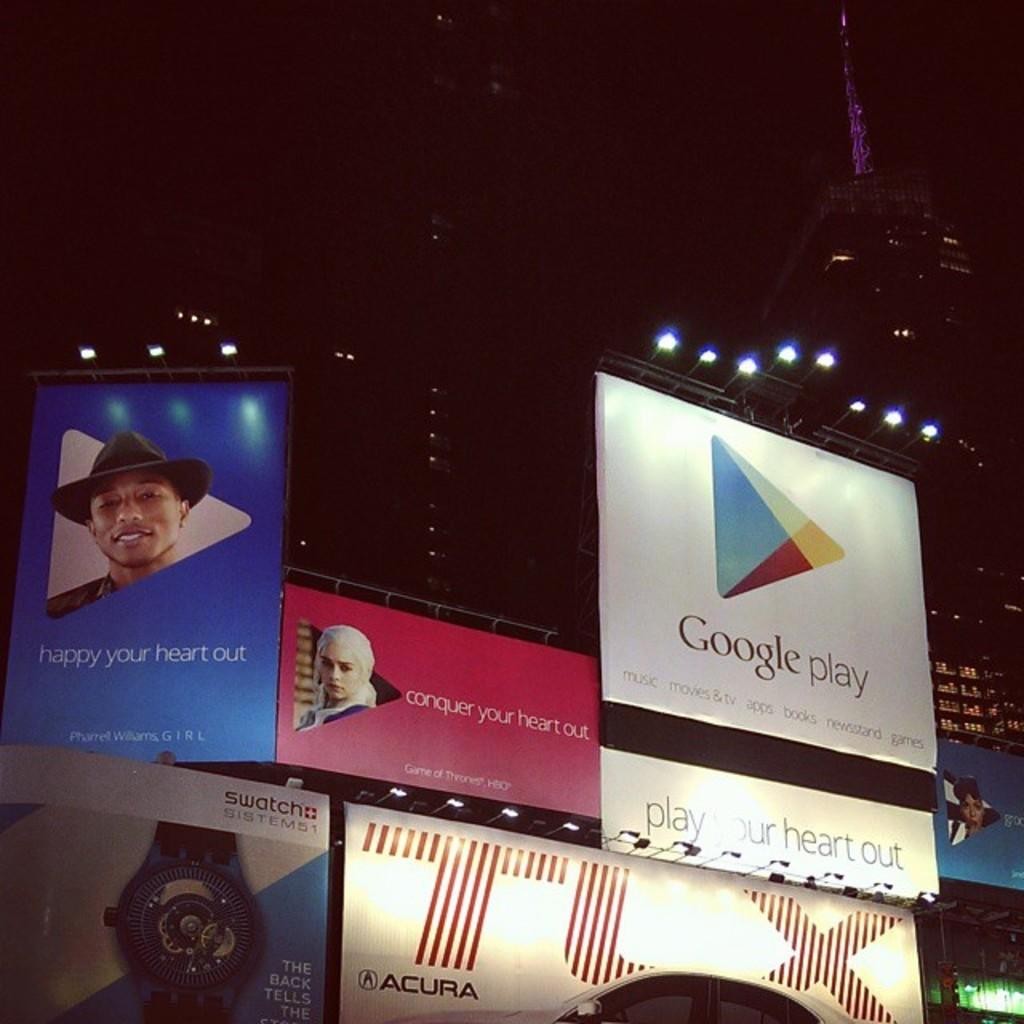<image>
Summarize the visual content of the image. A billboard for Google play in the city. 